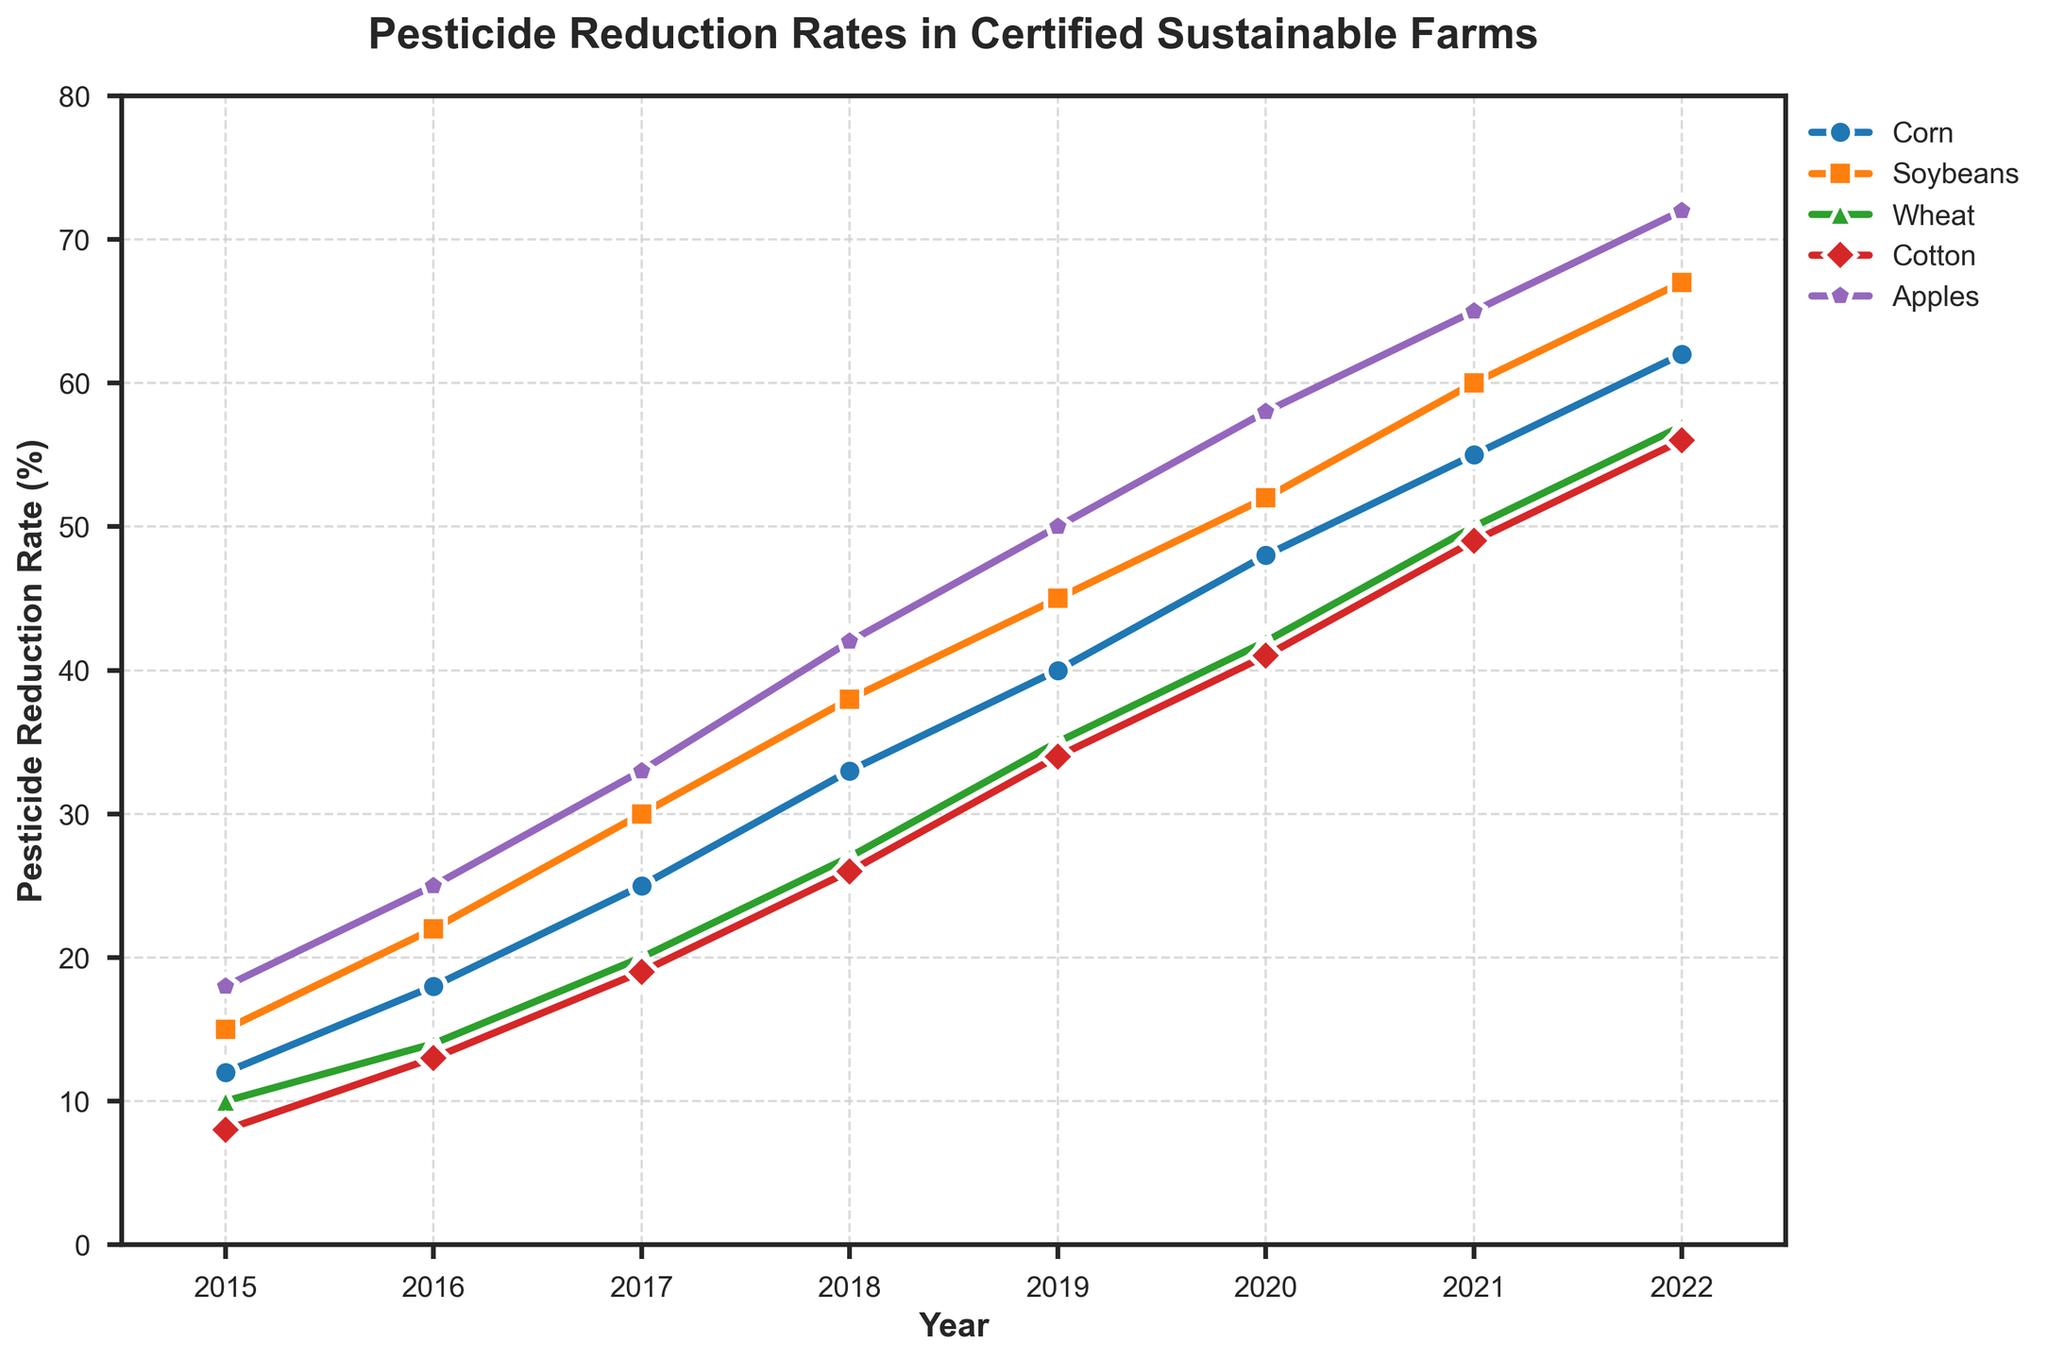When did the highest pesticide reduction rate for Corn occur? According to the line chart, the highest pesticide reduction rate for Corn is observed in 2022, where the rate is 62%.
Answer: 2022 Which crop consistently had the highest pesticide reduction rate from 2015 to 2022? By observing the position of the lines in the chart, Apples consistently had the highest pesticide reduction rate each year from 2015 to 2022.
Answer: Apples Between which years did Soybeans experience the highest increase in pesticide reduction? The line for Soybeans steeply rises between 2015 to 2016, indicating the most significant increase in that period, with a 7% increase (from 15% to 22%).
Answer: 2015 to 2016 What is the average pesticide reduction rate for Wheat in 2020 and 2021? The pesticide reduction rates for Wheat in 2020 and 2021 are 42% and 50%, respectively. Summing these gives 92, and the average is 92/2 = 46.
Answer: 46 Which crop had the lowest pesticide reduction rate in 2017, and what was the rate? Observing the positions of the lines in 2017, Cotton had the lowest pesticide reduction rate at 19%.
Answer: Cotton, 19% How much did the pesticide reduction rate for Cotton increase from 2015 to 2020? The pesticide reduction rate for Cotton was 8% in 2015 and 41% in 2020. The increase is 41 - 8 = 33%.
Answer: 33% In which year did Corn have a similar pesticide reduction rate to Wheat in 2021? By comparing the values, Corn in 2020 had a 48% reduction rate, similar to Wheat's 50% in 2021, with just a 2% difference.
Answer: 2020 What is the difference in the pesticide reduction rate between Apples and Cotton in 2018? The pesticide reduction rate for Apples in 2018 was 42%, and for Cotton, it was 26%. The difference is 42 - 26 = 16%.
Answer: 16% Which crop showed the steepest increase in pesticide reduction rate from 2019 to 2020? By observing the slope of the lines between these years, Apples showed the steepest increase, going from 50% to 58%, an increase of 8%.
Answer: Apples 